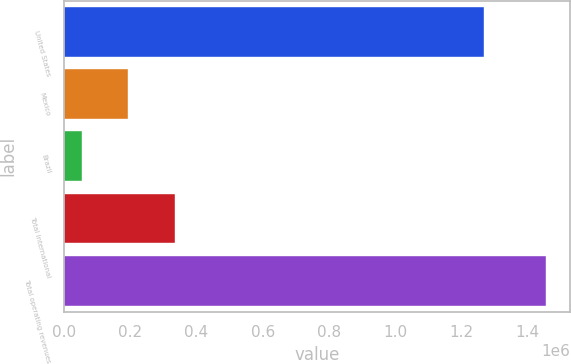<chart> <loc_0><loc_0><loc_500><loc_500><bar_chart><fcel>United States<fcel>Mexico<fcel>Brazil<fcel>Total International<fcel>Total operating revenues<nl><fcel>1.26832e+06<fcel>193790<fcel>53478<fcel>334101<fcel>1.45659e+06<nl></chart> 